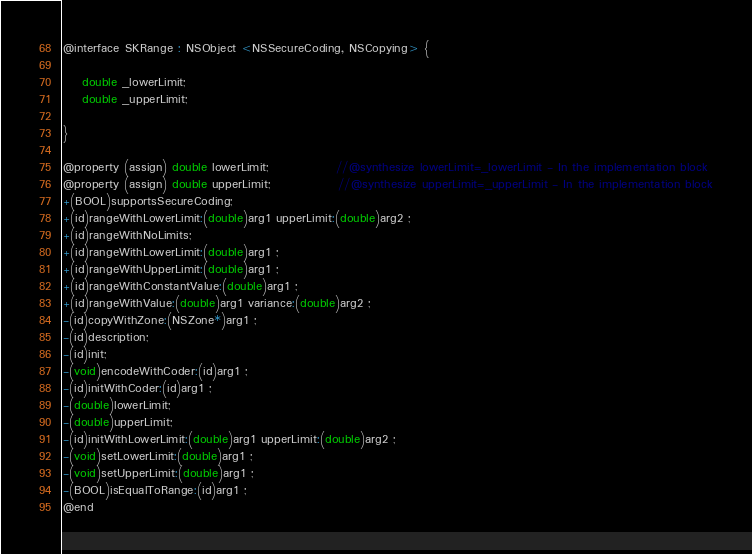<code> <loc_0><loc_0><loc_500><loc_500><_C_>
@interface SKRange : NSObject <NSSecureCoding, NSCopying> {

	double _lowerLimit;
	double _upperLimit;

}

@property (assign) double lowerLimit;              //@synthesize lowerLimit=_lowerLimit - In the implementation block
@property (assign) double upperLimit;              //@synthesize upperLimit=_upperLimit - In the implementation block
+(BOOL)supportsSecureCoding;
+(id)rangeWithLowerLimit:(double)arg1 upperLimit:(double)arg2 ;
+(id)rangeWithNoLimits;
+(id)rangeWithLowerLimit:(double)arg1 ;
+(id)rangeWithUpperLimit:(double)arg1 ;
+(id)rangeWithConstantValue:(double)arg1 ;
+(id)rangeWithValue:(double)arg1 variance:(double)arg2 ;
-(id)copyWithZone:(NSZone*)arg1 ;
-(id)description;
-(id)init;
-(void)encodeWithCoder:(id)arg1 ;
-(id)initWithCoder:(id)arg1 ;
-(double)lowerLimit;
-(double)upperLimit;
-(id)initWithLowerLimit:(double)arg1 upperLimit:(double)arg2 ;
-(void)setLowerLimit:(double)arg1 ;
-(void)setUpperLimit:(double)arg1 ;
-(BOOL)isEqualToRange:(id)arg1 ;
@end

</code> 